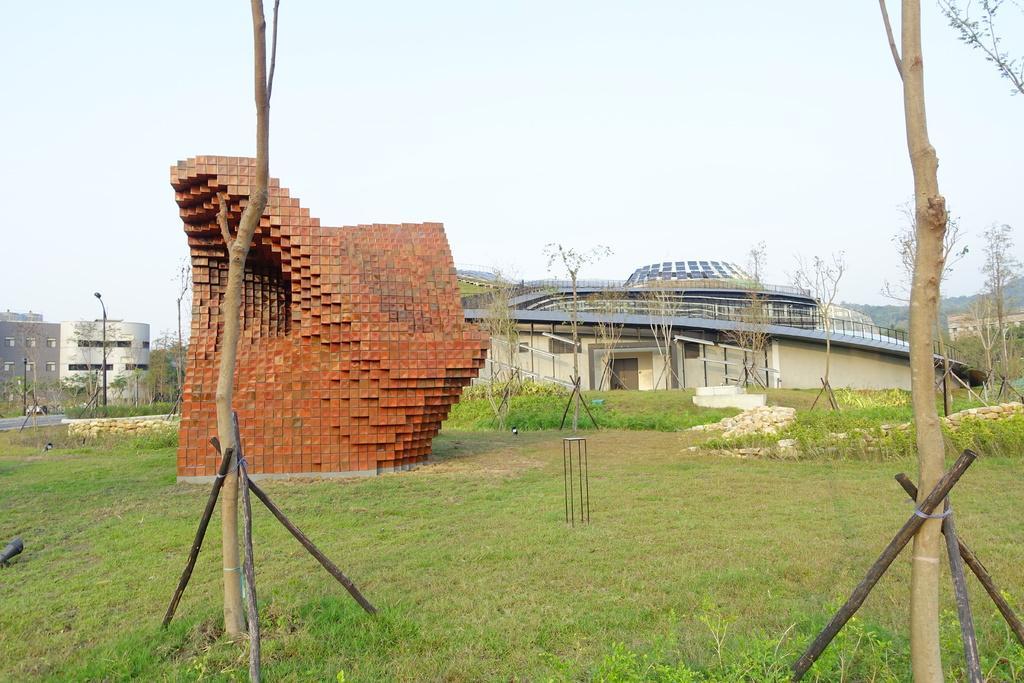How would you summarize this image in a sentence or two? In this picture there are few buildings and the ground is greenery and there are few trees in the background. 